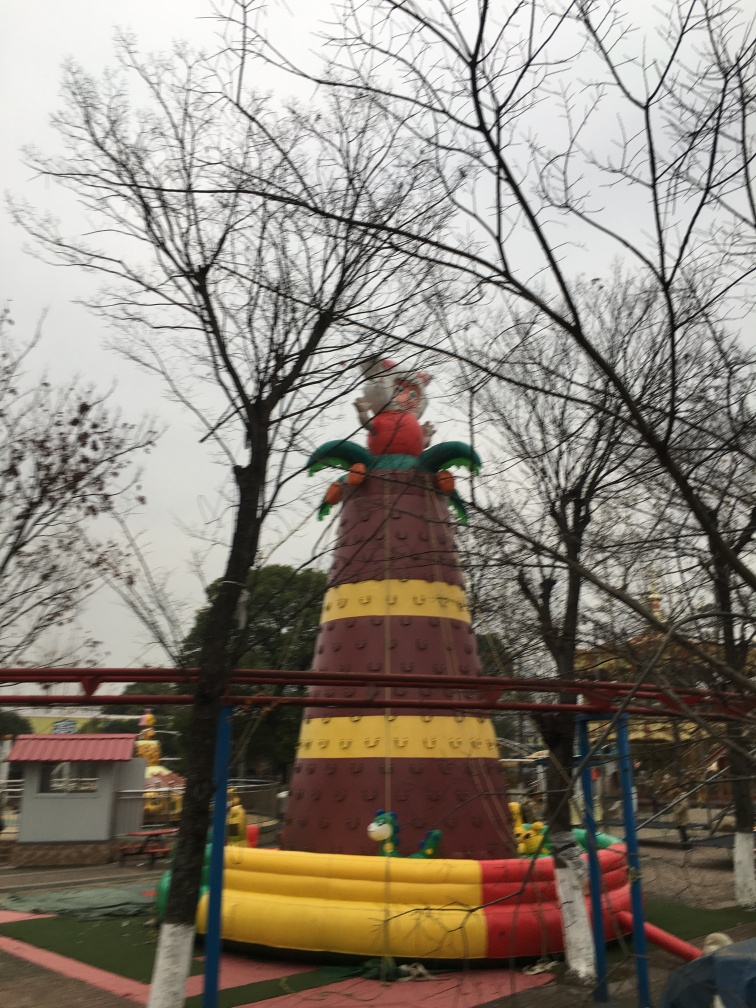Are there any people in the image? No, there are no people visible in the image, creating a sense of emptiness or abandonment in the playground area. 